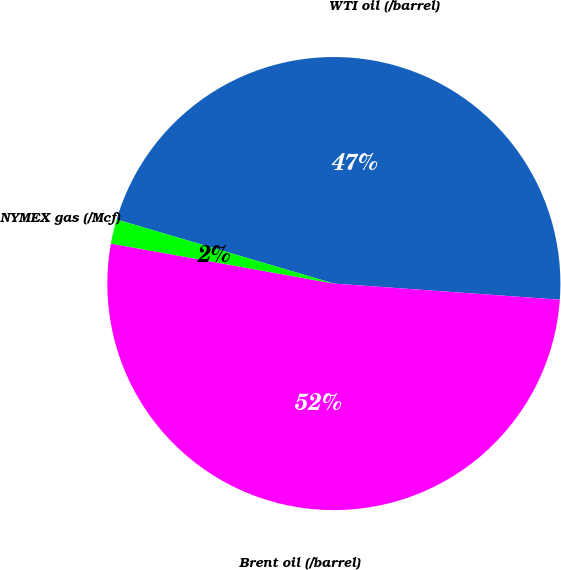Convert chart. <chart><loc_0><loc_0><loc_500><loc_500><pie_chart><fcel>WTI oil (/barrel)<fcel>Brent oil (/barrel)<fcel>NYMEX gas (/Mcf)<nl><fcel>46.57%<fcel>51.69%<fcel>1.74%<nl></chart> 